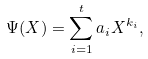Convert formula to latex. <formula><loc_0><loc_0><loc_500><loc_500>\Psi ( X ) = \sum _ { i = 1 } ^ { t } a _ { i } X ^ { k _ { i } } ,</formula> 